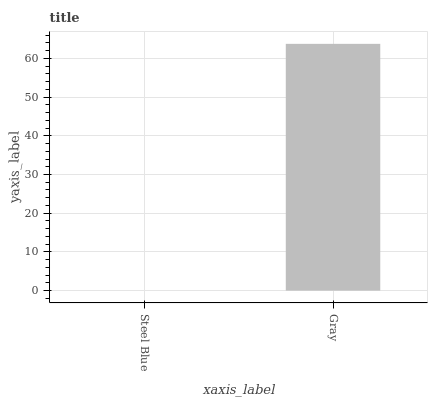Is Gray the minimum?
Answer yes or no. No. Is Gray greater than Steel Blue?
Answer yes or no. Yes. Is Steel Blue less than Gray?
Answer yes or no. Yes. Is Steel Blue greater than Gray?
Answer yes or no. No. Is Gray less than Steel Blue?
Answer yes or no. No. Is Gray the high median?
Answer yes or no. Yes. Is Steel Blue the low median?
Answer yes or no. Yes. Is Steel Blue the high median?
Answer yes or no. No. Is Gray the low median?
Answer yes or no. No. 